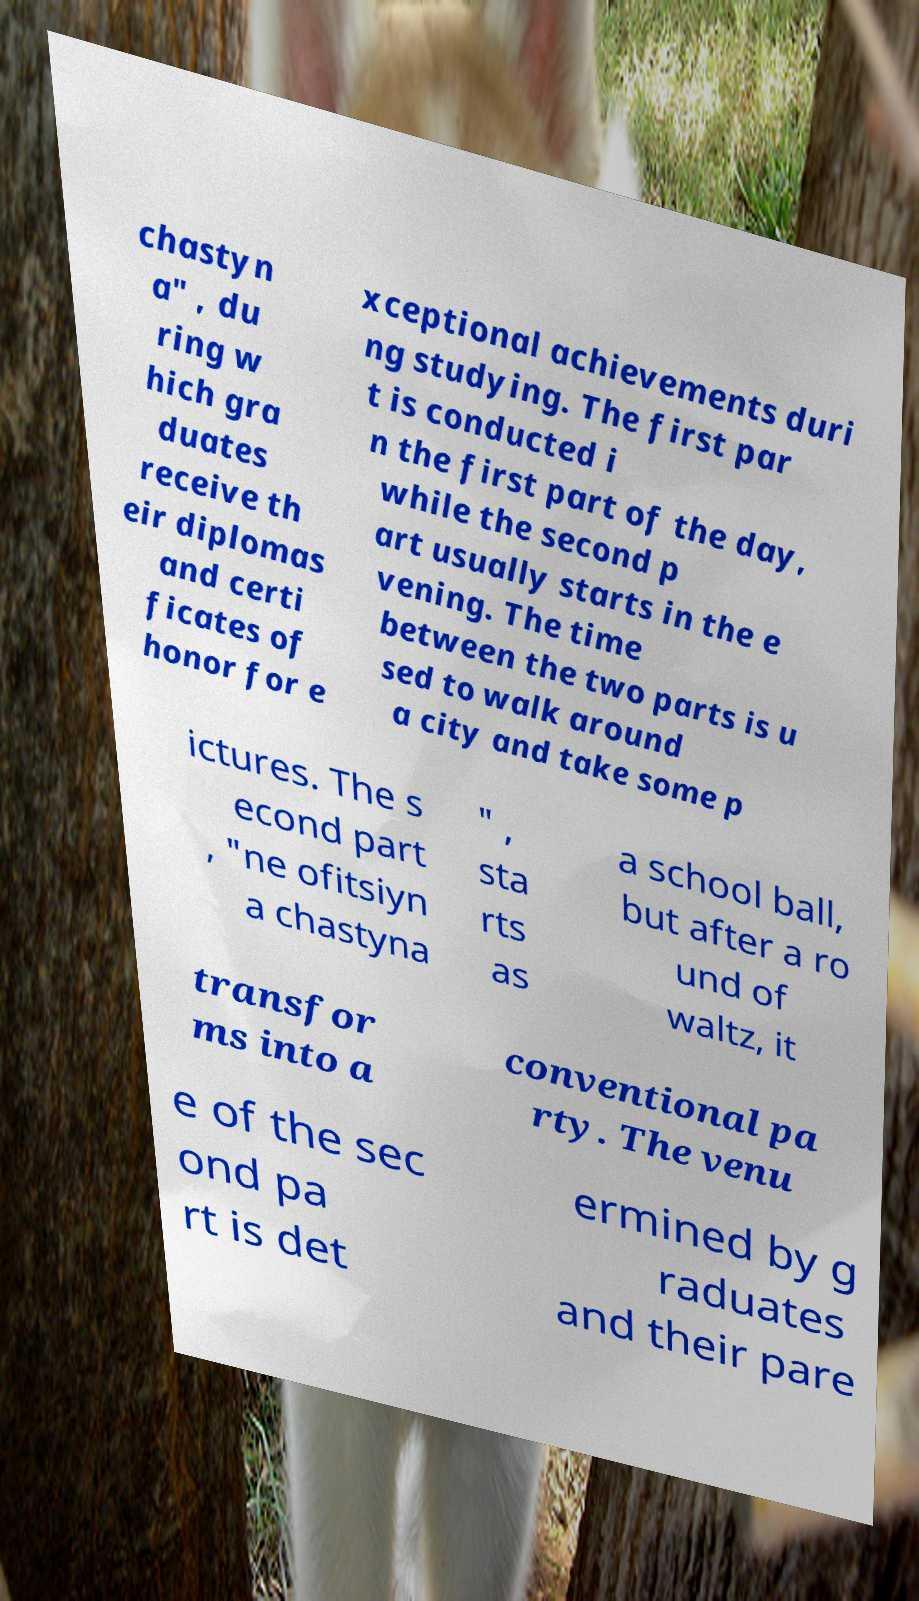I need the written content from this picture converted into text. Can you do that? chastyn a" , du ring w hich gra duates receive th eir diplomas and certi ficates of honor for e xceptional achievements duri ng studying. The first par t is conducted i n the first part of the day, while the second p art usually starts in the e vening. The time between the two parts is u sed to walk around a city and take some p ictures. The s econd part , "ne ofitsiyn a chastyna " , sta rts as a school ball, but after a ro und of waltz, it transfor ms into a conventional pa rty. The venu e of the sec ond pa rt is det ermined by g raduates and their pare 